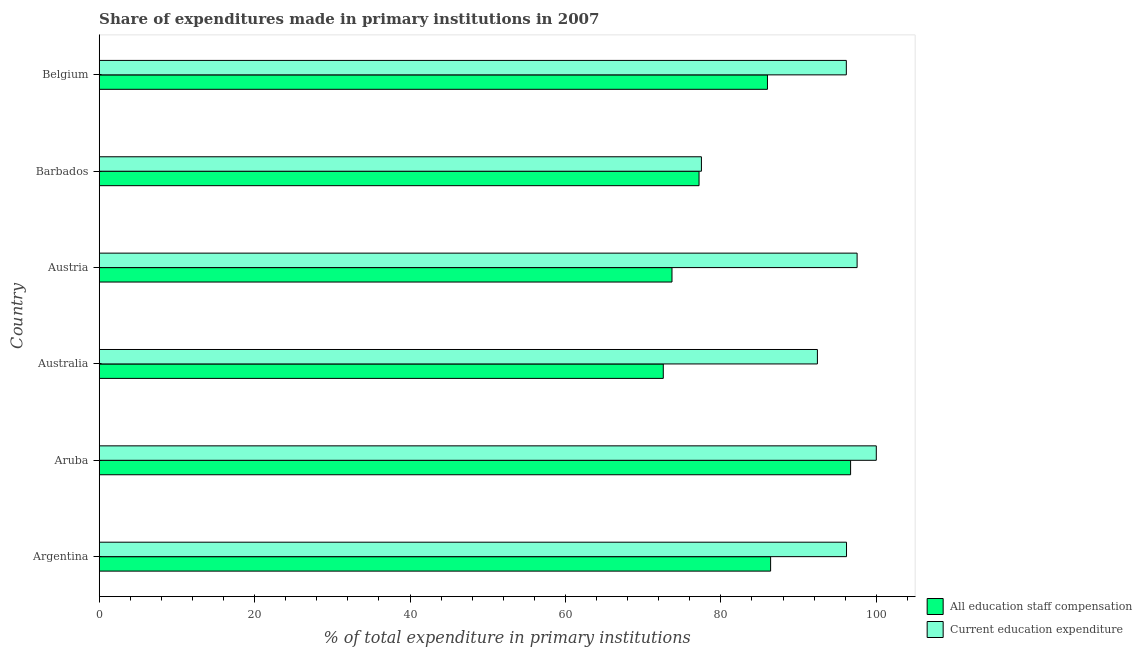How many different coloured bars are there?
Keep it short and to the point. 2. How many bars are there on the 5th tick from the top?
Your answer should be very brief. 2. How many bars are there on the 3rd tick from the bottom?
Offer a very short reply. 2. What is the label of the 5th group of bars from the top?
Provide a succinct answer. Aruba. In how many cases, is the number of bars for a given country not equal to the number of legend labels?
Ensure brevity in your answer.  0. What is the expenditure in staff compensation in Belgium?
Keep it short and to the point. 85.99. Across all countries, what is the maximum expenditure in education?
Offer a terse response. 100. Across all countries, what is the minimum expenditure in education?
Offer a very short reply. 77.5. In which country was the expenditure in staff compensation maximum?
Make the answer very short. Aruba. What is the total expenditure in staff compensation in the graph?
Keep it short and to the point. 492.57. What is the difference between the expenditure in education in Argentina and that in Aruba?
Keep it short and to the point. -3.83. What is the difference between the expenditure in staff compensation in Argentina and the expenditure in education in Austria?
Offer a very short reply. -11.13. What is the average expenditure in staff compensation per country?
Provide a succinct answer. 82.09. What is the difference between the expenditure in staff compensation and expenditure in education in Austria?
Your answer should be compact. -23.82. What is the ratio of the expenditure in staff compensation in Australia to that in Belgium?
Offer a terse response. 0.84. Is the expenditure in staff compensation in Aruba less than that in Belgium?
Offer a terse response. No. What is the difference between the highest and the second highest expenditure in staff compensation?
Keep it short and to the point. 10.29. Is the sum of the expenditure in staff compensation in Argentina and Barbados greater than the maximum expenditure in education across all countries?
Keep it short and to the point. Yes. What does the 1st bar from the top in Austria represents?
Offer a terse response. Current education expenditure. What does the 2nd bar from the bottom in Argentina represents?
Offer a very short reply. Current education expenditure. How many bars are there?
Offer a very short reply. 12. Are all the bars in the graph horizontal?
Your answer should be very brief. Yes. Does the graph contain grids?
Offer a very short reply. No. Where does the legend appear in the graph?
Offer a very short reply. Bottom right. What is the title of the graph?
Your answer should be compact. Share of expenditures made in primary institutions in 2007. Does "Constant 2005 US$" appear as one of the legend labels in the graph?
Provide a succinct answer. No. What is the label or title of the X-axis?
Keep it short and to the point. % of total expenditure in primary institutions. What is the % of total expenditure in primary institutions of All education staff compensation in Argentina?
Your response must be concise. 86.4. What is the % of total expenditure in primary institutions in Current education expenditure in Argentina?
Provide a short and direct response. 96.17. What is the % of total expenditure in primary institutions of All education staff compensation in Aruba?
Make the answer very short. 96.69. What is the % of total expenditure in primary institutions of All education staff compensation in Australia?
Provide a short and direct response. 72.59. What is the % of total expenditure in primary institutions of Current education expenditure in Australia?
Your response must be concise. 92.42. What is the % of total expenditure in primary institutions of All education staff compensation in Austria?
Your answer should be compact. 73.71. What is the % of total expenditure in primary institutions in Current education expenditure in Austria?
Give a very brief answer. 97.53. What is the % of total expenditure in primary institutions of All education staff compensation in Barbados?
Ensure brevity in your answer.  77.19. What is the % of total expenditure in primary institutions in Current education expenditure in Barbados?
Your answer should be very brief. 77.5. What is the % of total expenditure in primary institutions of All education staff compensation in Belgium?
Your response must be concise. 85.99. What is the % of total expenditure in primary institutions of Current education expenditure in Belgium?
Offer a very short reply. 96.14. Across all countries, what is the maximum % of total expenditure in primary institutions in All education staff compensation?
Offer a very short reply. 96.69. Across all countries, what is the minimum % of total expenditure in primary institutions of All education staff compensation?
Make the answer very short. 72.59. Across all countries, what is the minimum % of total expenditure in primary institutions in Current education expenditure?
Make the answer very short. 77.5. What is the total % of total expenditure in primary institutions of All education staff compensation in the graph?
Your answer should be compact. 492.57. What is the total % of total expenditure in primary institutions in Current education expenditure in the graph?
Give a very brief answer. 559.76. What is the difference between the % of total expenditure in primary institutions of All education staff compensation in Argentina and that in Aruba?
Your answer should be compact. -10.29. What is the difference between the % of total expenditure in primary institutions of Current education expenditure in Argentina and that in Aruba?
Provide a short and direct response. -3.83. What is the difference between the % of total expenditure in primary institutions in All education staff compensation in Argentina and that in Australia?
Ensure brevity in your answer.  13.81. What is the difference between the % of total expenditure in primary institutions in Current education expenditure in Argentina and that in Australia?
Provide a succinct answer. 3.75. What is the difference between the % of total expenditure in primary institutions in All education staff compensation in Argentina and that in Austria?
Offer a very short reply. 12.69. What is the difference between the % of total expenditure in primary institutions of Current education expenditure in Argentina and that in Austria?
Offer a terse response. -1.36. What is the difference between the % of total expenditure in primary institutions of All education staff compensation in Argentina and that in Barbados?
Offer a terse response. 9.21. What is the difference between the % of total expenditure in primary institutions in Current education expenditure in Argentina and that in Barbados?
Keep it short and to the point. 18.67. What is the difference between the % of total expenditure in primary institutions in All education staff compensation in Argentina and that in Belgium?
Offer a terse response. 0.41. What is the difference between the % of total expenditure in primary institutions of Current education expenditure in Argentina and that in Belgium?
Provide a succinct answer. 0.02. What is the difference between the % of total expenditure in primary institutions of All education staff compensation in Aruba and that in Australia?
Ensure brevity in your answer.  24.1. What is the difference between the % of total expenditure in primary institutions in Current education expenditure in Aruba and that in Australia?
Your answer should be compact. 7.58. What is the difference between the % of total expenditure in primary institutions in All education staff compensation in Aruba and that in Austria?
Provide a short and direct response. 22.98. What is the difference between the % of total expenditure in primary institutions of Current education expenditure in Aruba and that in Austria?
Make the answer very short. 2.47. What is the difference between the % of total expenditure in primary institutions in All education staff compensation in Aruba and that in Barbados?
Your response must be concise. 19.5. What is the difference between the % of total expenditure in primary institutions of Current education expenditure in Aruba and that in Barbados?
Your response must be concise. 22.5. What is the difference between the % of total expenditure in primary institutions in All education staff compensation in Aruba and that in Belgium?
Make the answer very short. 10.7. What is the difference between the % of total expenditure in primary institutions of Current education expenditure in Aruba and that in Belgium?
Make the answer very short. 3.86. What is the difference between the % of total expenditure in primary institutions in All education staff compensation in Australia and that in Austria?
Make the answer very short. -1.12. What is the difference between the % of total expenditure in primary institutions in Current education expenditure in Australia and that in Austria?
Offer a terse response. -5.11. What is the difference between the % of total expenditure in primary institutions of All education staff compensation in Australia and that in Barbados?
Give a very brief answer. -4.6. What is the difference between the % of total expenditure in primary institutions in Current education expenditure in Australia and that in Barbados?
Offer a terse response. 14.93. What is the difference between the % of total expenditure in primary institutions in All education staff compensation in Australia and that in Belgium?
Keep it short and to the point. -13.4. What is the difference between the % of total expenditure in primary institutions of Current education expenditure in Australia and that in Belgium?
Keep it short and to the point. -3.72. What is the difference between the % of total expenditure in primary institutions of All education staff compensation in Austria and that in Barbados?
Make the answer very short. -3.48. What is the difference between the % of total expenditure in primary institutions in Current education expenditure in Austria and that in Barbados?
Offer a very short reply. 20.03. What is the difference between the % of total expenditure in primary institutions of All education staff compensation in Austria and that in Belgium?
Provide a short and direct response. -12.29. What is the difference between the % of total expenditure in primary institutions in Current education expenditure in Austria and that in Belgium?
Your answer should be very brief. 1.39. What is the difference between the % of total expenditure in primary institutions in All education staff compensation in Barbados and that in Belgium?
Your response must be concise. -8.8. What is the difference between the % of total expenditure in primary institutions of Current education expenditure in Barbados and that in Belgium?
Offer a terse response. -18.65. What is the difference between the % of total expenditure in primary institutions in All education staff compensation in Argentina and the % of total expenditure in primary institutions in Current education expenditure in Aruba?
Your answer should be very brief. -13.6. What is the difference between the % of total expenditure in primary institutions in All education staff compensation in Argentina and the % of total expenditure in primary institutions in Current education expenditure in Australia?
Offer a very short reply. -6.02. What is the difference between the % of total expenditure in primary institutions of All education staff compensation in Argentina and the % of total expenditure in primary institutions of Current education expenditure in Austria?
Offer a very short reply. -11.13. What is the difference between the % of total expenditure in primary institutions of All education staff compensation in Argentina and the % of total expenditure in primary institutions of Current education expenditure in Barbados?
Provide a short and direct response. 8.9. What is the difference between the % of total expenditure in primary institutions of All education staff compensation in Argentina and the % of total expenditure in primary institutions of Current education expenditure in Belgium?
Offer a terse response. -9.74. What is the difference between the % of total expenditure in primary institutions in All education staff compensation in Aruba and the % of total expenditure in primary institutions in Current education expenditure in Australia?
Your response must be concise. 4.27. What is the difference between the % of total expenditure in primary institutions in All education staff compensation in Aruba and the % of total expenditure in primary institutions in Current education expenditure in Austria?
Your answer should be compact. -0.84. What is the difference between the % of total expenditure in primary institutions of All education staff compensation in Aruba and the % of total expenditure in primary institutions of Current education expenditure in Barbados?
Keep it short and to the point. 19.2. What is the difference between the % of total expenditure in primary institutions in All education staff compensation in Aruba and the % of total expenditure in primary institutions in Current education expenditure in Belgium?
Give a very brief answer. 0.55. What is the difference between the % of total expenditure in primary institutions of All education staff compensation in Australia and the % of total expenditure in primary institutions of Current education expenditure in Austria?
Provide a succinct answer. -24.94. What is the difference between the % of total expenditure in primary institutions of All education staff compensation in Australia and the % of total expenditure in primary institutions of Current education expenditure in Barbados?
Offer a terse response. -4.91. What is the difference between the % of total expenditure in primary institutions of All education staff compensation in Australia and the % of total expenditure in primary institutions of Current education expenditure in Belgium?
Make the answer very short. -23.56. What is the difference between the % of total expenditure in primary institutions in All education staff compensation in Austria and the % of total expenditure in primary institutions in Current education expenditure in Barbados?
Your answer should be very brief. -3.79. What is the difference between the % of total expenditure in primary institutions in All education staff compensation in Austria and the % of total expenditure in primary institutions in Current education expenditure in Belgium?
Offer a terse response. -22.44. What is the difference between the % of total expenditure in primary institutions of All education staff compensation in Barbados and the % of total expenditure in primary institutions of Current education expenditure in Belgium?
Give a very brief answer. -18.95. What is the average % of total expenditure in primary institutions in All education staff compensation per country?
Ensure brevity in your answer.  82.1. What is the average % of total expenditure in primary institutions of Current education expenditure per country?
Ensure brevity in your answer.  93.29. What is the difference between the % of total expenditure in primary institutions of All education staff compensation and % of total expenditure in primary institutions of Current education expenditure in Argentina?
Your answer should be very brief. -9.77. What is the difference between the % of total expenditure in primary institutions in All education staff compensation and % of total expenditure in primary institutions in Current education expenditure in Aruba?
Offer a terse response. -3.31. What is the difference between the % of total expenditure in primary institutions of All education staff compensation and % of total expenditure in primary institutions of Current education expenditure in Australia?
Provide a succinct answer. -19.83. What is the difference between the % of total expenditure in primary institutions of All education staff compensation and % of total expenditure in primary institutions of Current education expenditure in Austria?
Give a very brief answer. -23.82. What is the difference between the % of total expenditure in primary institutions of All education staff compensation and % of total expenditure in primary institutions of Current education expenditure in Barbados?
Keep it short and to the point. -0.31. What is the difference between the % of total expenditure in primary institutions in All education staff compensation and % of total expenditure in primary institutions in Current education expenditure in Belgium?
Offer a very short reply. -10.15. What is the ratio of the % of total expenditure in primary institutions of All education staff compensation in Argentina to that in Aruba?
Offer a very short reply. 0.89. What is the ratio of the % of total expenditure in primary institutions in Current education expenditure in Argentina to that in Aruba?
Offer a terse response. 0.96. What is the ratio of the % of total expenditure in primary institutions of All education staff compensation in Argentina to that in Australia?
Provide a succinct answer. 1.19. What is the ratio of the % of total expenditure in primary institutions of Current education expenditure in Argentina to that in Australia?
Give a very brief answer. 1.04. What is the ratio of the % of total expenditure in primary institutions of All education staff compensation in Argentina to that in Austria?
Keep it short and to the point. 1.17. What is the ratio of the % of total expenditure in primary institutions in All education staff compensation in Argentina to that in Barbados?
Provide a short and direct response. 1.12. What is the ratio of the % of total expenditure in primary institutions in Current education expenditure in Argentina to that in Barbados?
Your response must be concise. 1.24. What is the ratio of the % of total expenditure in primary institutions of All education staff compensation in Argentina to that in Belgium?
Keep it short and to the point. 1. What is the ratio of the % of total expenditure in primary institutions in All education staff compensation in Aruba to that in Australia?
Make the answer very short. 1.33. What is the ratio of the % of total expenditure in primary institutions in Current education expenditure in Aruba to that in Australia?
Offer a terse response. 1.08. What is the ratio of the % of total expenditure in primary institutions in All education staff compensation in Aruba to that in Austria?
Provide a short and direct response. 1.31. What is the ratio of the % of total expenditure in primary institutions in Current education expenditure in Aruba to that in Austria?
Offer a terse response. 1.03. What is the ratio of the % of total expenditure in primary institutions of All education staff compensation in Aruba to that in Barbados?
Your answer should be compact. 1.25. What is the ratio of the % of total expenditure in primary institutions of Current education expenditure in Aruba to that in Barbados?
Make the answer very short. 1.29. What is the ratio of the % of total expenditure in primary institutions in All education staff compensation in Aruba to that in Belgium?
Your answer should be compact. 1.12. What is the ratio of the % of total expenditure in primary institutions in Current education expenditure in Aruba to that in Belgium?
Ensure brevity in your answer.  1.04. What is the ratio of the % of total expenditure in primary institutions in Current education expenditure in Australia to that in Austria?
Provide a succinct answer. 0.95. What is the ratio of the % of total expenditure in primary institutions of All education staff compensation in Australia to that in Barbados?
Your answer should be compact. 0.94. What is the ratio of the % of total expenditure in primary institutions of Current education expenditure in Australia to that in Barbados?
Your answer should be very brief. 1.19. What is the ratio of the % of total expenditure in primary institutions in All education staff compensation in Australia to that in Belgium?
Keep it short and to the point. 0.84. What is the ratio of the % of total expenditure in primary institutions of Current education expenditure in Australia to that in Belgium?
Your response must be concise. 0.96. What is the ratio of the % of total expenditure in primary institutions of All education staff compensation in Austria to that in Barbados?
Give a very brief answer. 0.95. What is the ratio of the % of total expenditure in primary institutions of Current education expenditure in Austria to that in Barbados?
Make the answer very short. 1.26. What is the ratio of the % of total expenditure in primary institutions of All education staff compensation in Austria to that in Belgium?
Make the answer very short. 0.86. What is the ratio of the % of total expenditure in primary institutions of Current education expenditure in Austria to that in Belgium?
Provide a succinct answer. 1.01. What is the ratio of the % of total expenditure in primary institutions in All education staff compensation in Barbados to that in Belgium?
Ensure brevity in your answer.  0.9. What is the ratio of the % of total expenditure in primary institutions of Current education expenditure in Barbados to that in Belgium?
Your response must be concise. 0.81. What is the difference between the highest and the second highest % of total expenditure in primary institutions in All education staff compensation?
Keep it short and to the point. 10.29. What is the difference between the highest and the second highest % of total expenditure in primary institutions of Current education expenditure?
Provide a short and direct response. 2.47. What is the difference between the highest and the lowest % of total expenditure in primary institutions in All education staff compensation?
Your response must be concise. 24.1. What is the difference between the highest and the lowest % of total expenditure in primary institutions of Current education expenditure?
Provide a short and direct response. 22.5. 